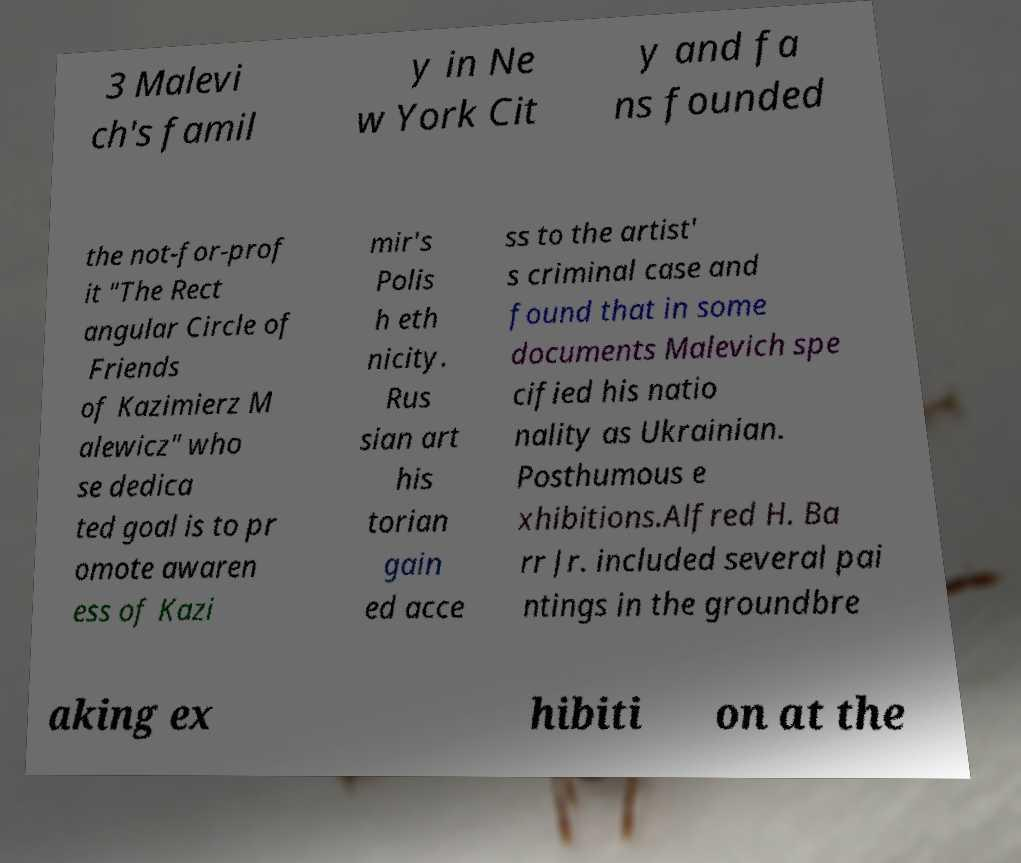What messages or text are displayed in this image? I need them in a readable, typed format. 3 Malevi ch's famil y in Ne w York Cit y and fa ns founded the not-for-prof it "The Rect angular Circle of Friends of Kazimierz M alewicz" who se dedica ted goal is to pr omote awaren ess of Kazi mir's Polis h eth nicity. Rus sian art his torian gain ed acce ss to the artist' s criminal case and found that in some documents Malevich spe cified his natio nality as Ukrainian. Posthumous e xhibitions.Alfred H. Ba rr Jr. included several pai ntings in the groundbre aking ex hibiti on at the 